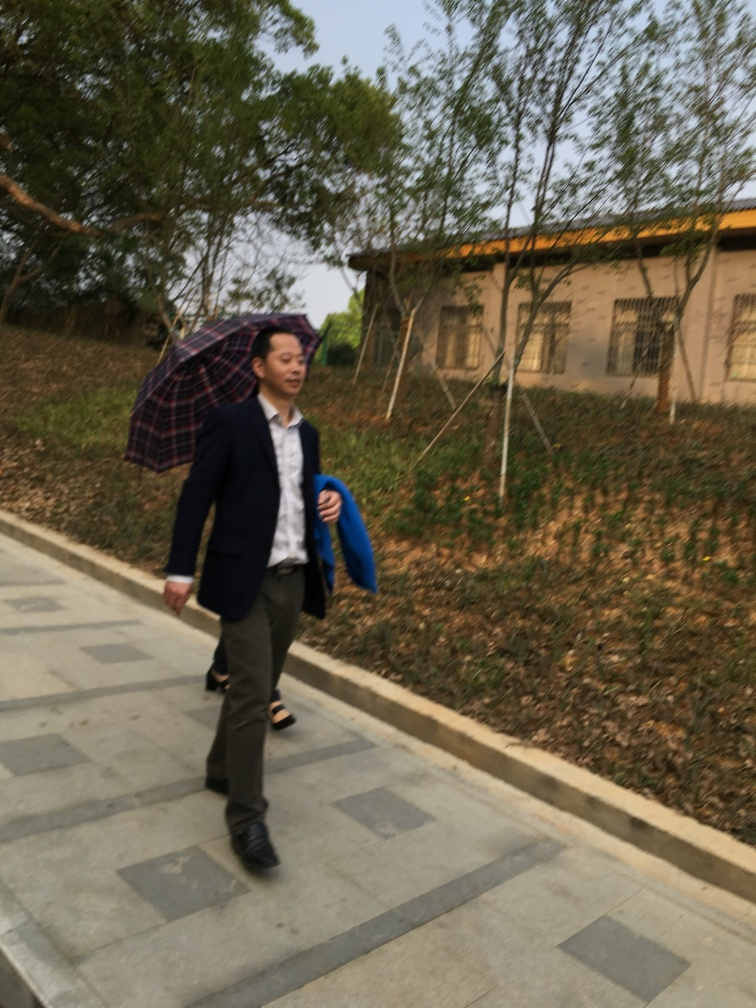What can you infer about the person's mood or situation? The person seems to be walking with a sense of purpose and is adequately dressed in business attire, implying they might be headed to or from a work-related location. The umbrella might suggest a readiness for inclement weather, and the individual doesn't appear hurried, which could indicate a relaxed or neutral mood. 